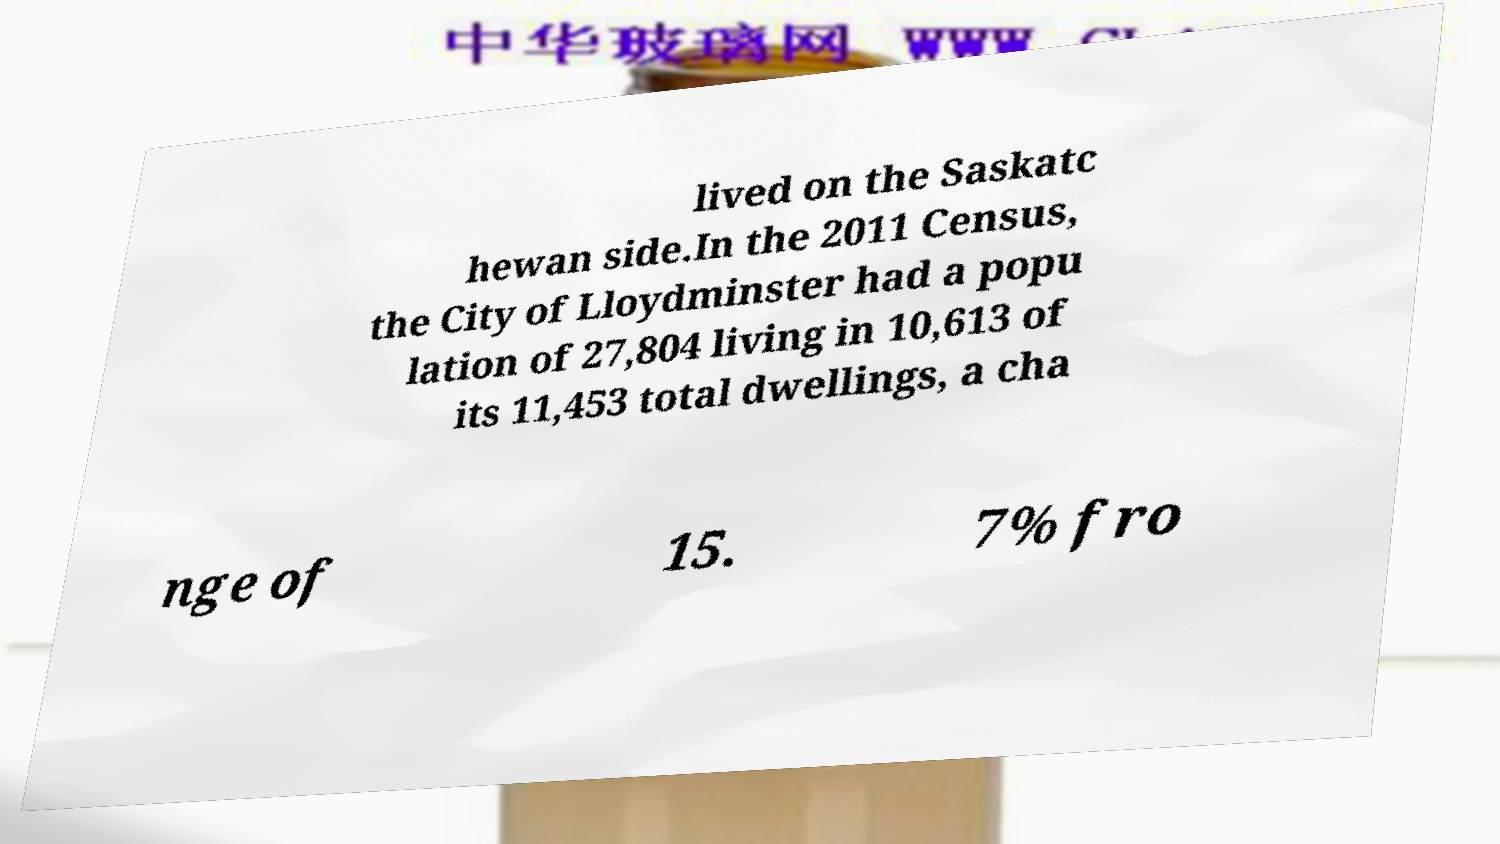Please read and relay the text visible in this image. What does it say? lived on the Saskatc hewan side.In the 2011 Census, the City of Lloydminster had a popu lation of 27,804 living in 10,613 of its 11,453 total dwellings, a cha nge of 15. 7% fro 